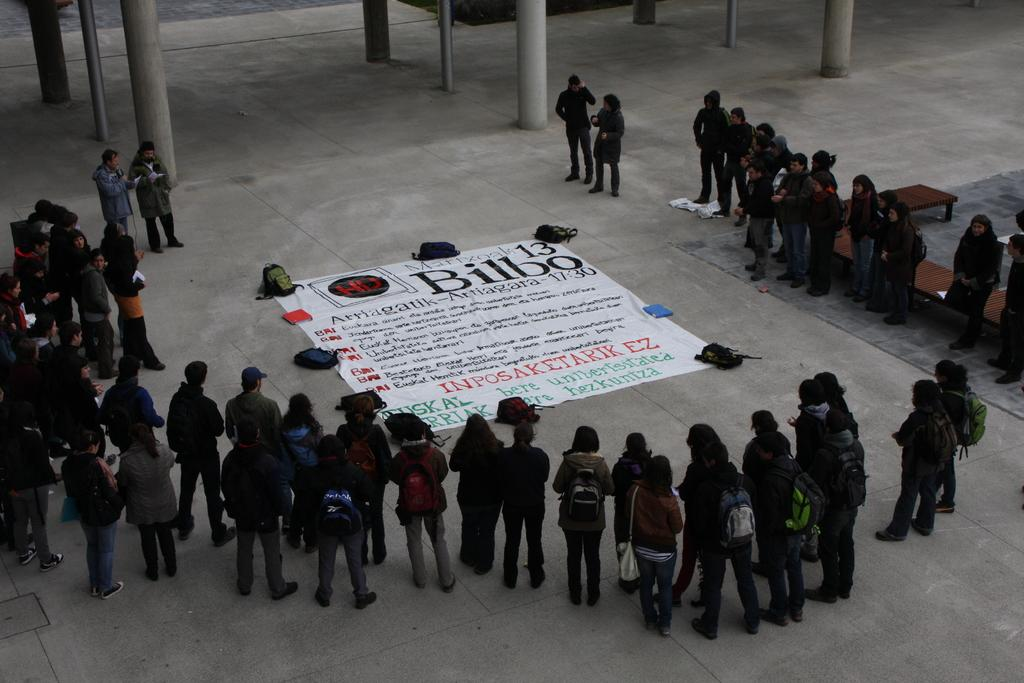What is happening in the image? There are people standing in the image. What is on the floor in the image? There is a banner onner on the floor in the image. What items are the people carrying? Backpacks are visible in the image. What can be seen in the background of the image? There are pillars in the background of the image. What type of appliance is being used by the people in the image? There is no appliance visible in the image; the people are simply standing. How many spoons can be seen in the image? There are no spoons present in the image. 